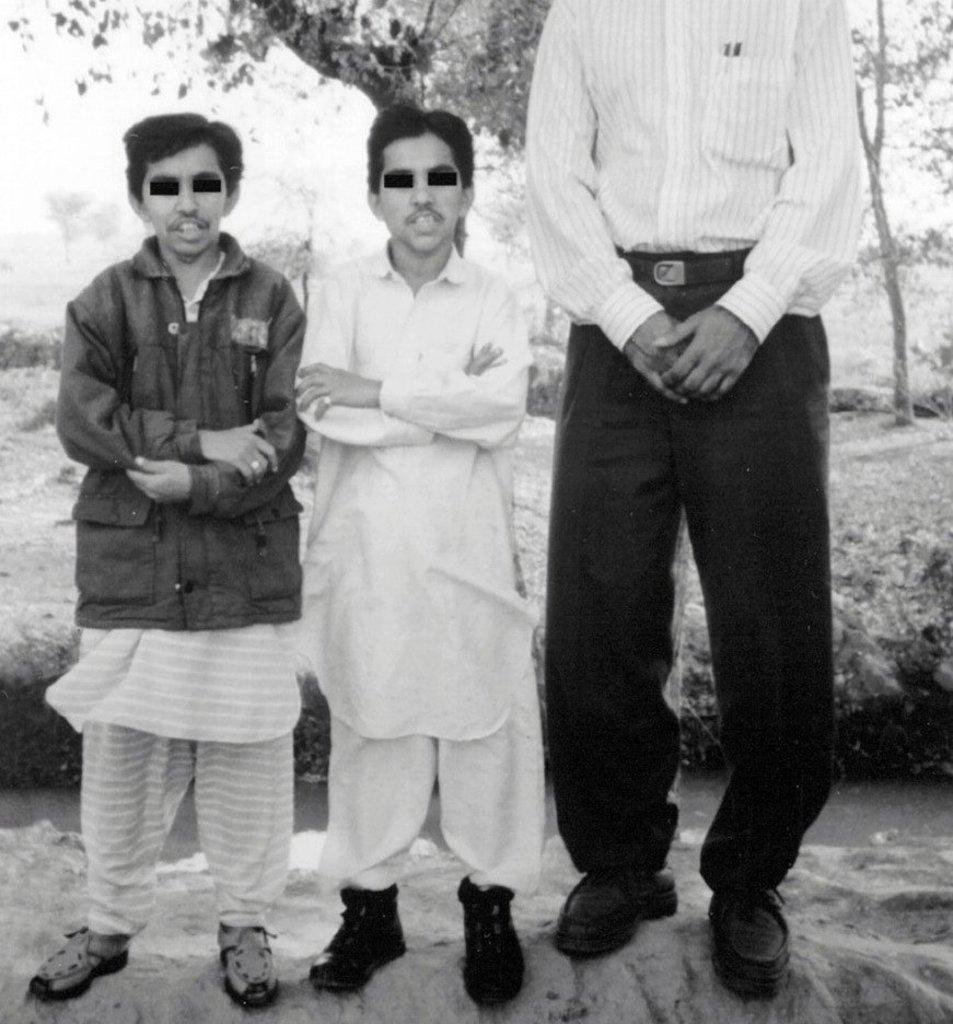What is the color scheme of the image? The image is black and white. How many people are in the image? There are three persons standing in the middle of the image. What can be seen in the background of the image? There are trees in the background of the image. What type of poison is being used by the person on the left in the image? There is no poison or indication of poison use in the image; it features three people standing in the middle of the image. What is the zephyr doing in the image? There is no zephyr present in the image; it is a black and white image of three people standing in the middle of the image with trees in the background. 